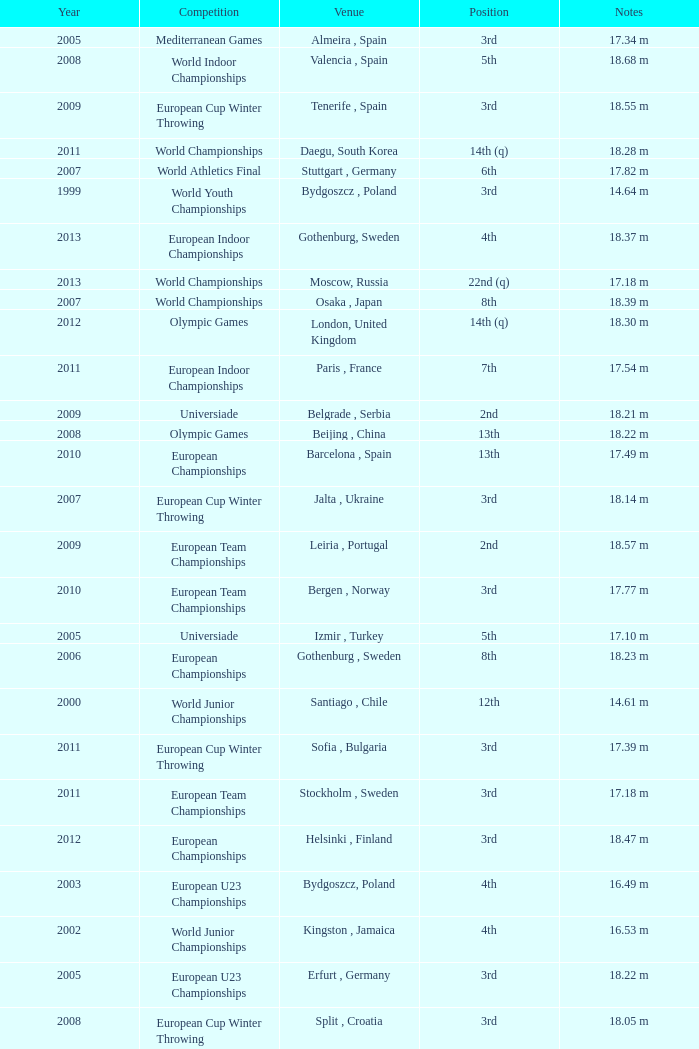What are the notes for bydgoszcz, Poland? 14.64 m, 16.49 m. 